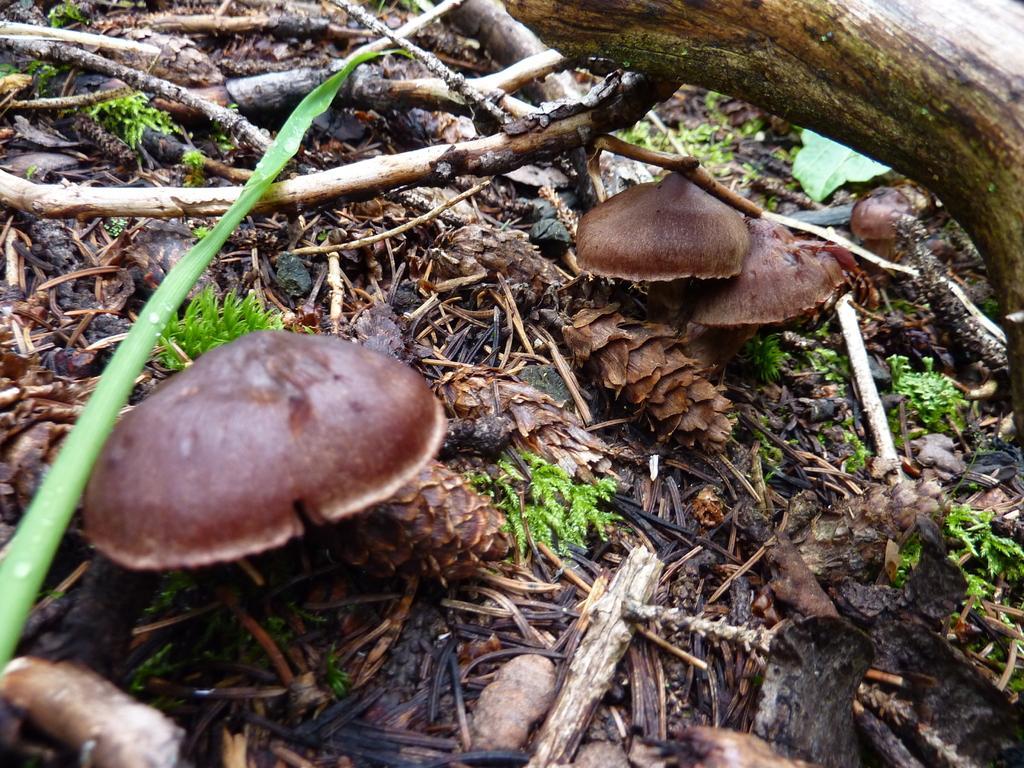Describe this image in one or two sentences. In this image we can see mushrooms. Also there are wooden pieces and there are few plants and there is a leaf. 